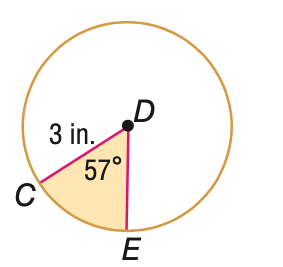Answer the mathemtical geometry problem and directly provide the correct option letter.
Question: Find the area of the shaded sector. Round to the nearest tenth.
Choices: A: 3.0 B: 4.5 C: 23.8 D: 28.3 B 